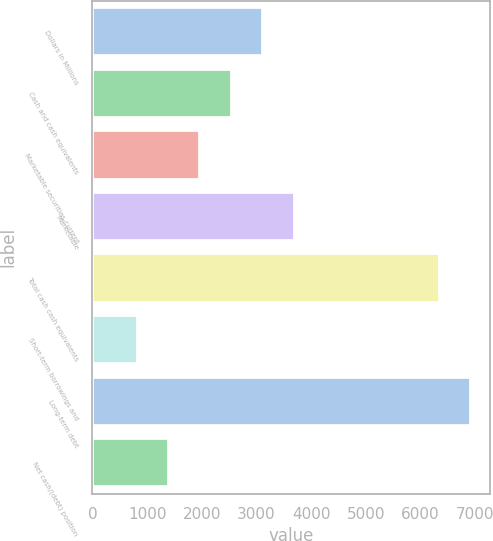<chart> <loc_0><loc_0><loc_500><loc_500><bar_chart><fcel>Dollars in Millions<fcel>Cash and cash equivalents<fcel>Marketable securities-current<fcel>Marketable<fcel>Total cash cash equivalents<fcel>Short-term borrowings and<fcel>Long-term debt<fcel>Net cash/(debt) position<nl><fcel>3122.8<fcel>2548.6<fcel>1974.4<fcel>3697<fcel>6352<fcel>826<fcel>6926.2<fcel>1400.2<nl></chart> 